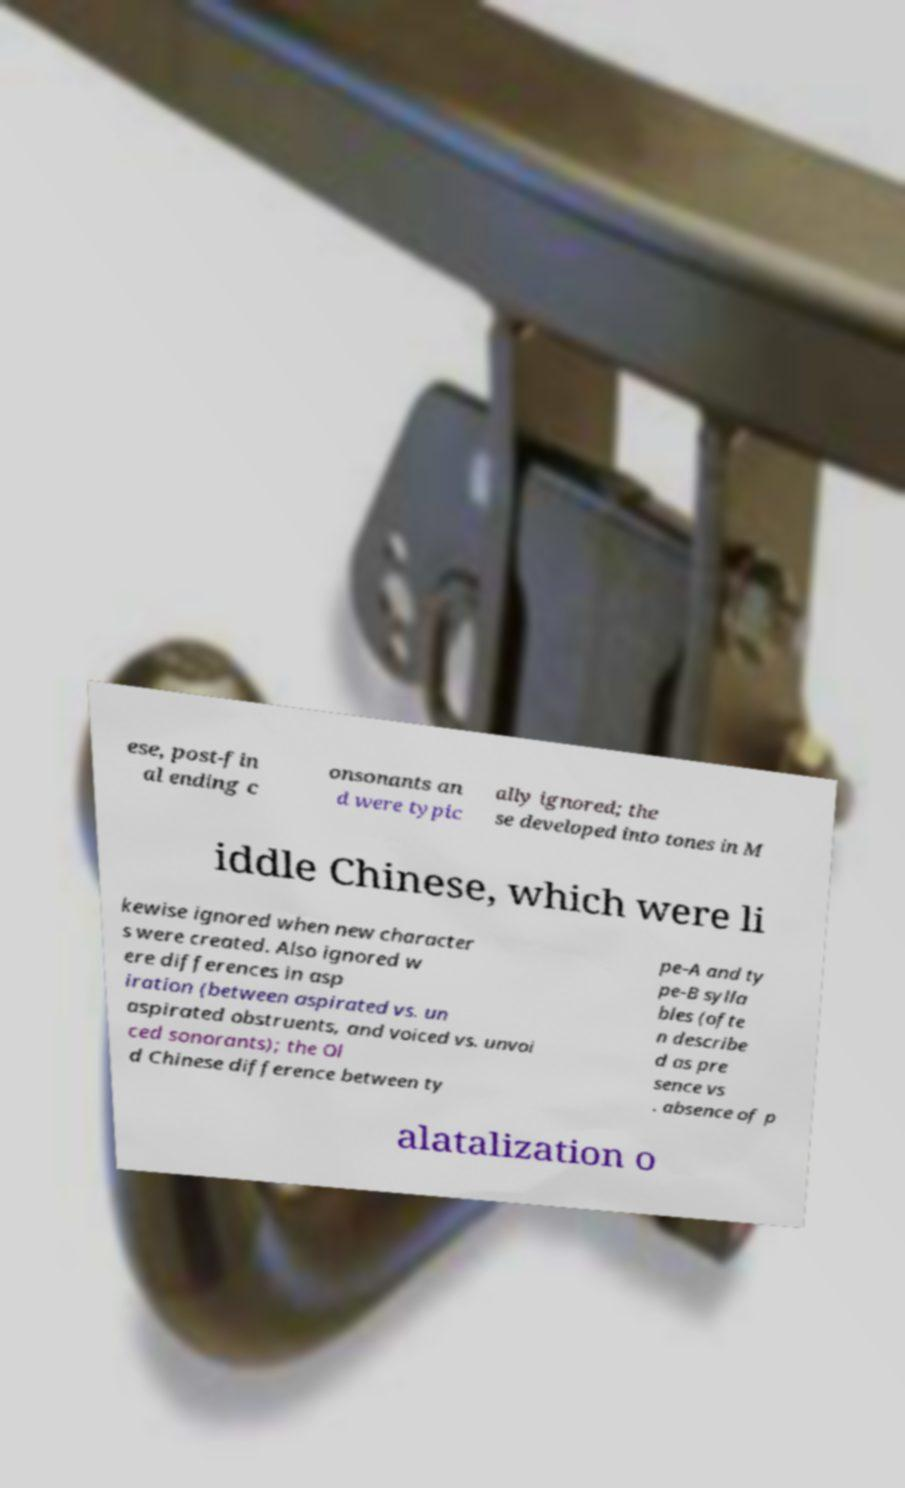For documentation purposes, I need the text within this image transcribed. Could you provide that? ese, post-fin al ending c onsonants an d were typic ally ignored; the se developed into tones in M iddle Chinese, which were li kewise ignored when new character s were created. Also ignored w ere differences in asp iration (between aspirated vs. un aspirated obstruents, and voiced vs. unvoi ced sonorants); the Ol d Chinese difference between ty pe-A and ty pe-B sylla bles (ofte n describe d as pre sence vs . absence of p alatalization o 